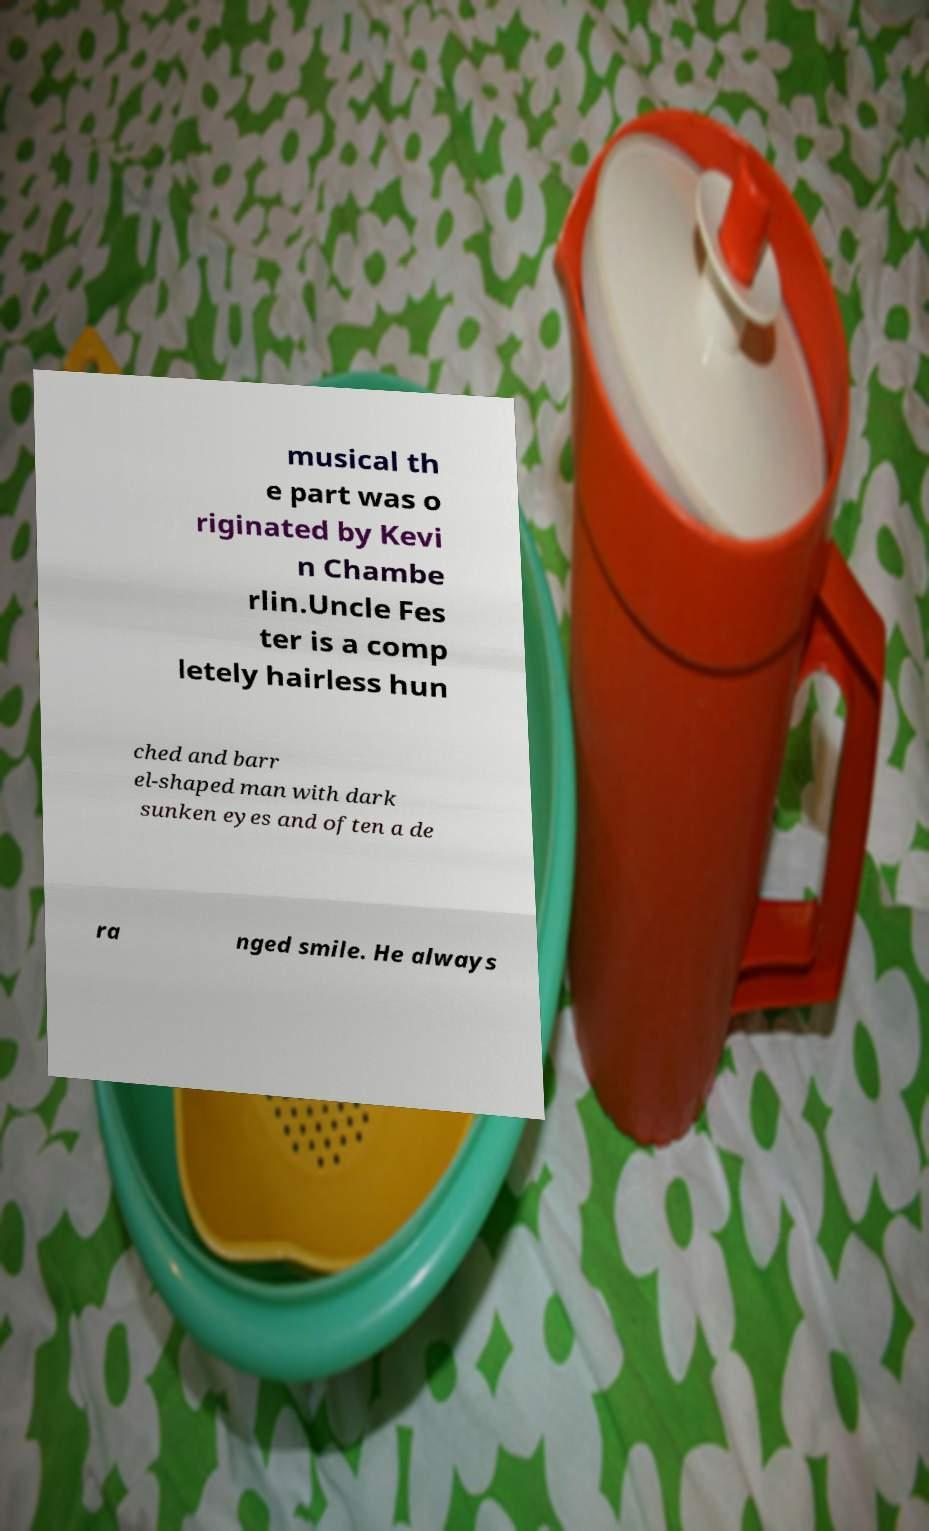For documentation purposes, I need the text within this image transcribed. Could you provide that? musical th e part was o riginated by Kevi n Chambe rlin.Uncle Fes ter is a comp letely hairless hun ched and barr el-shaped man with dark sunken eyes and often a de ra nged smile. He always 